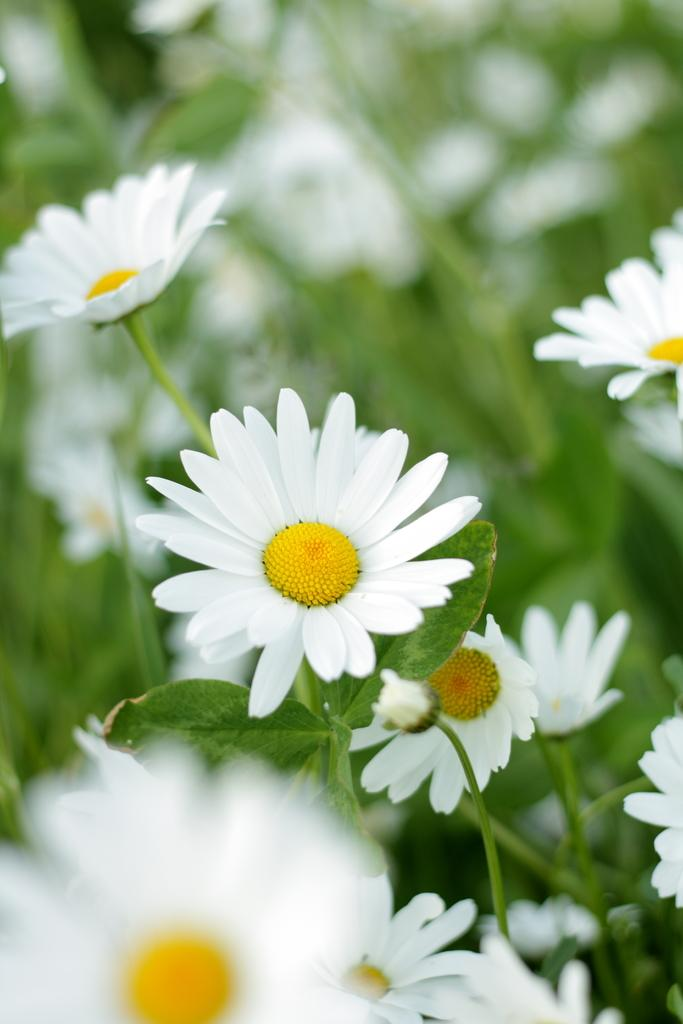What type of living organisms can be seen in the image? There are flowers in the image. Where are the flowers located on the plants? The flowers are present on plants. What type of anger can be seen on the faces of the people in the office in the image? There are no people or offices present in the image; it features flowers on plants. What type of chain can be seen connecting the flowers in the image? There is no chain present in the image; the flowers are on plants. 